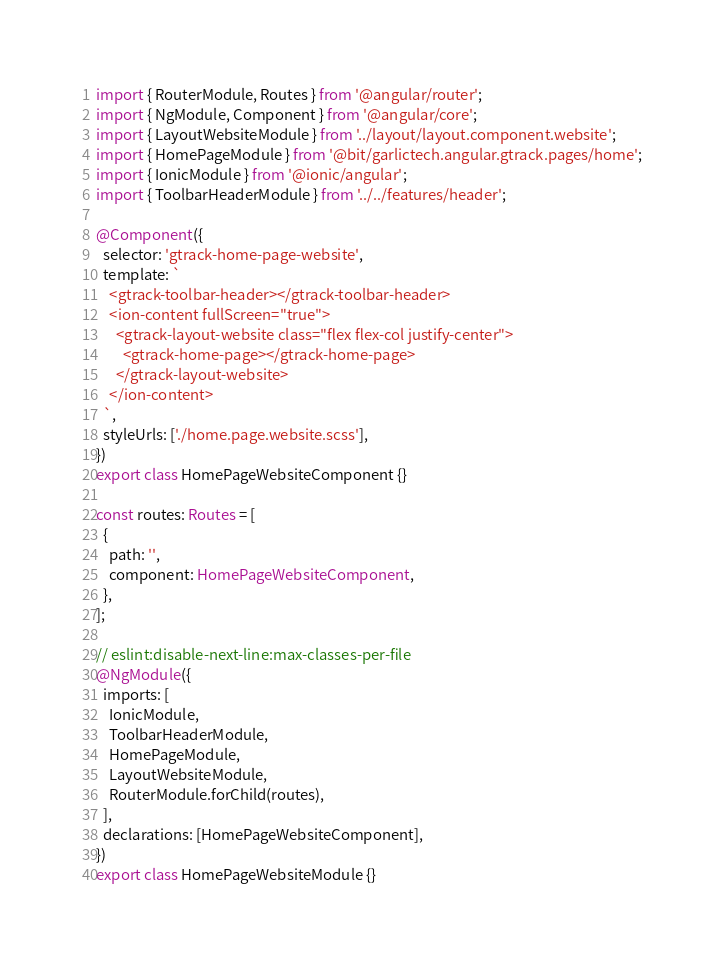<code> <loc_0><loc_0><loc_500><loc_500><_TypeScript_>import { RouterModule, Routes } from '@angular/router';
import { NgModule, Component } from '@angular/core';
import { LayoutWebsiteModule } from '../layout/layout.component.website';
import { HomePageModule } from '@bit/garlictech.angular.gtrack.pages/home';
import { IonicModule } from '@ionic/angular';
import { ToolbarHeaderModule } from '../../features/header';

@Component({
  selector: 'gtrack-home-page-website',
  template: `
    <gtrack-toolbar-header></gtrack-toolbar-header>
    <ion-content fullScreen="true">
      <gtrack-layout-website class="flex flex-col justify-center">
        <gtrack-home-page></gtrack-home-page>
      </gtrack-layout-website>
    </ion-content>
  `,
  styleUrls: ['./home.page.website.scss'],
})
export class HomePageWebsiteComponent {}

const routes: Routes = [
  {
    path: '',
    component: HomePageWebsiteComponent,
  },
];

// eslint:disable-next-line:max-classes-per-file
@NgModule({
  imports: [
    IonicModule,
    ToolbarHeaderModule,
    HomePageModule,
    LayoutWebsiteModule,
    RouterModule.forChild(routes),
  ],
  declarations: [HomePageWebsiteComponent],
})
export class HomePageWebsiteModule {}
</code> 